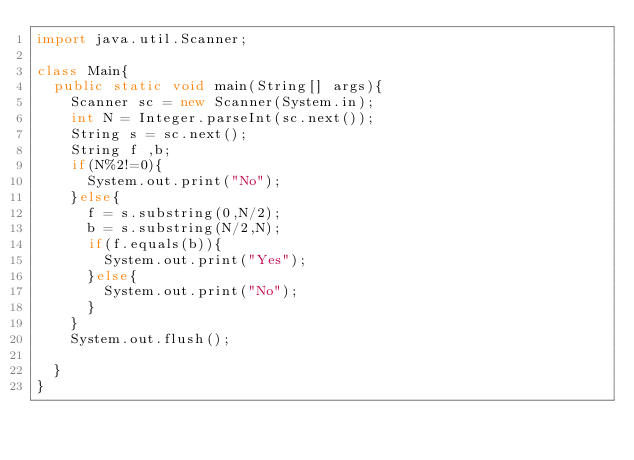<code> <loc_0><loc_0><loc_500><loc_500><_Java_>import java.util.Scanner;

class Main{
  public static void main(String[] args){
    Scanner sc = new Scanner(System.in);
    int N = Integer.parseInt(sc.next());
    String s = sc.next();
    String f ,b;
    if(N%2!=0){
      System.out.print("No");
    }else{
      f = s.substring(0,N/2);
      b = s.substring(N/2,N);
      if(f.equals(b)){
        System.out.print("Yes");
      }else{
        System.out.print("No");
      }
    }
    System.out.flush();
    
  }
}</code> 